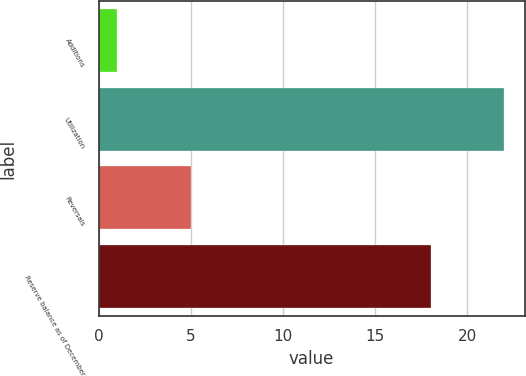Convert chart to OTSL. <chart><loc_0><loc_0><loc_500><loc_500><bar_chart><fcel>Additions<fcel>Utilization<fcel>Reversals<fcel>Reserve balance as of December<nl><fcel>1<fcel>22<fcel>5<fcel>18<nl></chart> 